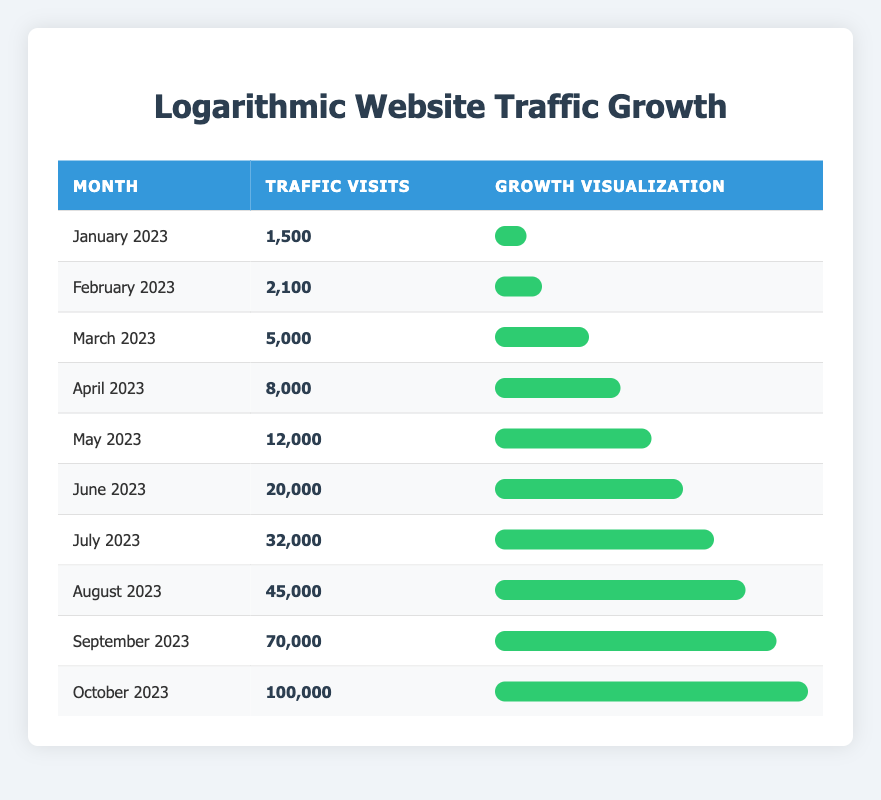What was the website traffic in June 2023? Referring to the table, the traffic visits for June 2023 are listed directly. They show that there were 20,000 visits that month.
Answer: 20,000 Which month had a traffic visit count greater than 30,000? Looking through the months listed, July has 32,000 visits, August has 45,000 visits, September has 70,000 visits, and October has 100,000 visits. The first month with over 30,000 visits is July 2023.
Answer: July 2023 What is the difference in traffic visits between April 2023 and May 2023? The traffic visits in April 2023 are 8,000 and in May 2023 are 12,000. To find the difference, subtract April from May: 12,000 - 8,000 equals 4,000.
Answer: 4,000 Is the traffic in September 2023 higher than that in May 2023? Comparing the two months, September has 70,000 visits and May has 12,000. Thus, September's visits are indeed higher than May's.
Answer: Yes What is the total website traffic for the first half of the year (January to June 2023)? To find the total traffic, sum the visits from January to June: 1,500 (Jan) + 2,100 (Feb) + 5,000 (Mar) + 8,000 (Apr) + 12,000 (May) + 20,000 (Jun) = 48,600.
Answer: 48,600 Which month saw the highest traffic growth percentage compared to the previous month? Calculate the growth from each month to the next: 40% (Jan to Feb), 138% (Feb to Mar), 60% (Mar to Apr), 50% (Apr to May), 67% (May to Jun), 60% (Jun to Jul), 60% (Jul to Aug), 56% (Aug to Sep), and 43% (Sep to Oct). The highest growth was from February to March at 138%.
Answer: February to March How many months had traffic visits below 5,000? Checking the data, both January (1,500) and February (2,100) had visits below 5,000, totaling 2 months.
Answer: 2 months What is the average monthly traffic visits for the entire year covered in the table? First, sum all monthly visits: 1,500 + 2,100 + 5,000 + 8,000 + 12,000 + 20,000 + 32,000 + 45,000 + 70,000 + 100,000 = 295,600. Divide by 10 months gives: 295,600 / 10 = 29,560.
Answer: 29,560 Was the total traffic growth from January 2023 to October 2023 more than 90,000 visits? The visits in January 2023 are 1,500 and in October 2023 are 100,000. The growth is 100,000 - 1,500 = 98,500. Since 98,500 is greater than 90,000, the statement is true.
Answer: Yes 